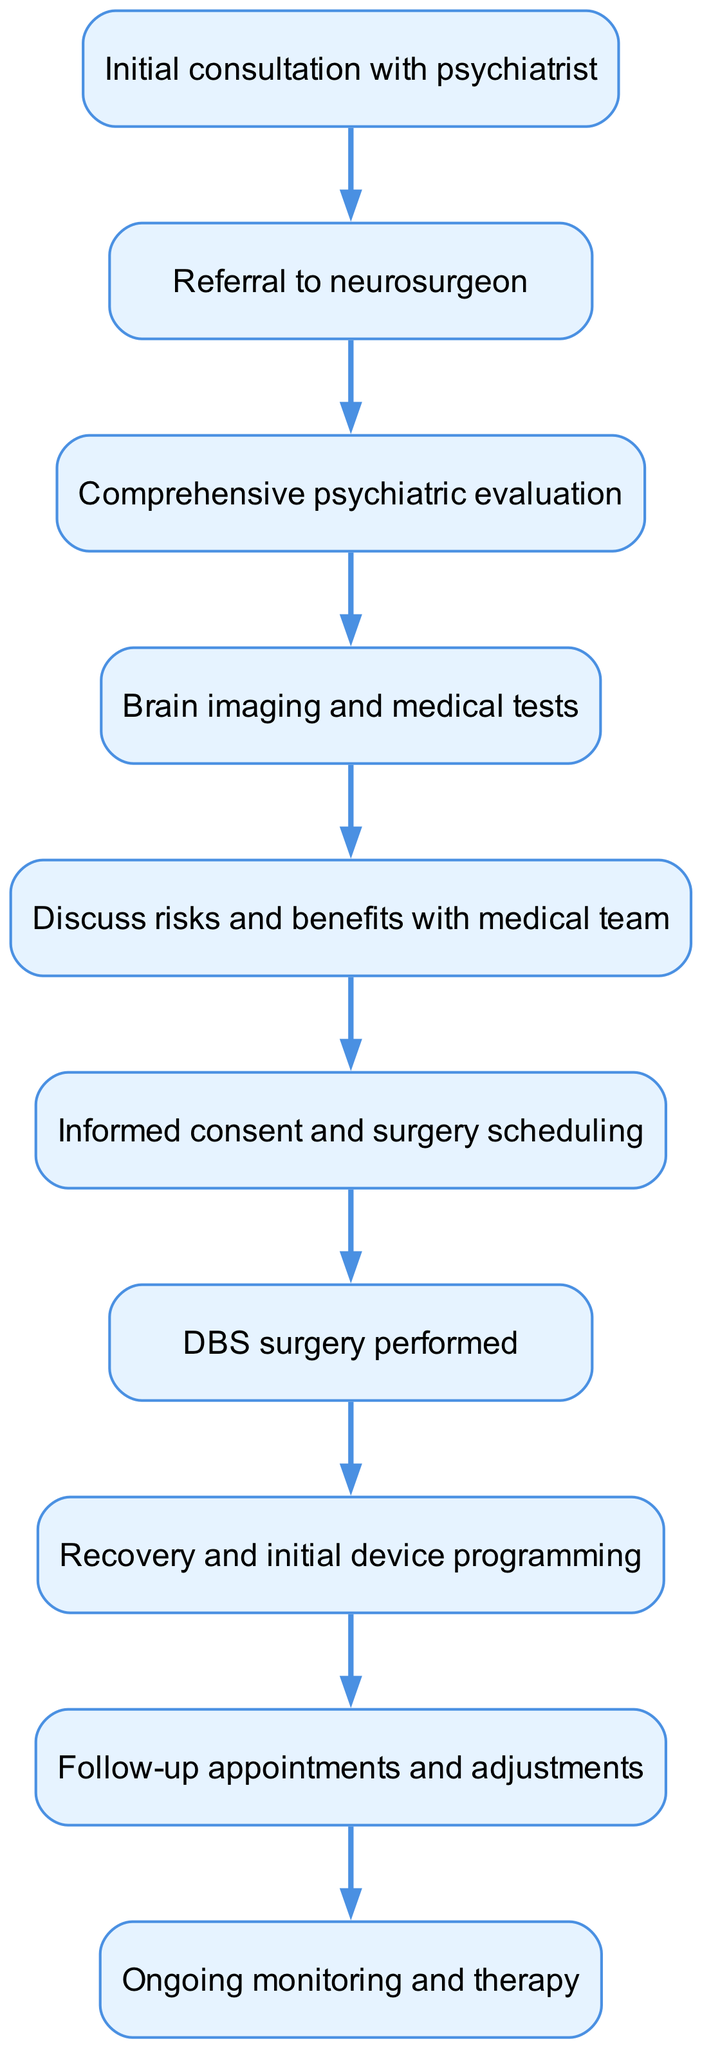What is the first step in the DBS surgery process? The first step in the process is indicated by the topmost node in the diagram, which is labeled "Initial consultation with psychiatrist."
Answer: Initial consultation with psychiatrist How many total steps are listed in the DBS surgery process? Counting the nodes in the diagram, there are 10 distinct steps identified in the flow.
Answer: 10 Which node comes directly after "Brain imaging and medical tests"? Following the flow of the diagram from the "Brain imaging and medical tests" node, the next node is "Discuss risks and benefits with medical team."
Answer: Discuss risks and benefits with medical team What step must occur immediately before the DBS surgery is performed? In reviewing the connections, the node labeled "Informed consent and surgery scheduling" must occur immediately before the "DBS surgery performed" node.
Answer: Informed consent and surgery scheduling What is the last step in the DBS surgery process? The last step is indicated by the final node in the diagram, which is labeled "Ongoing monitoring and therapy."
Answer: Ongoing monitoring and therapy Which step includes discussions about potential surgery risks? The step that contains discussions about risks is the node labeled "Discuss risks and benefits with medical team."
Answer: Discuss risks and benefits with medical team What is the relationship between "Comprehensive psychiatric evaluation" and "Referral to neurosurgeon"? The diagram shows that the "Referral to neurosurgeon" follows the "Comprehensive psychiatric evaluation," indicating a directional relationship where the first step leads to the second.
Answer: Referral to neurosurgeon How many follow-up appointments are indicated in the process? The diagram indicates a process that includes the node "Follow-up appointments and adjustments," which implies at least one follow-up appointment after surgery.
Answer: 1 Which two nodes are connected directly before the recovery phase? The diagram shows that "DBS surgery performed" connects directly to "Recovery and initial device programming," indicating these two nodes are sequential.
Answer: DBS surgery performed and Recovery and initial device programming 